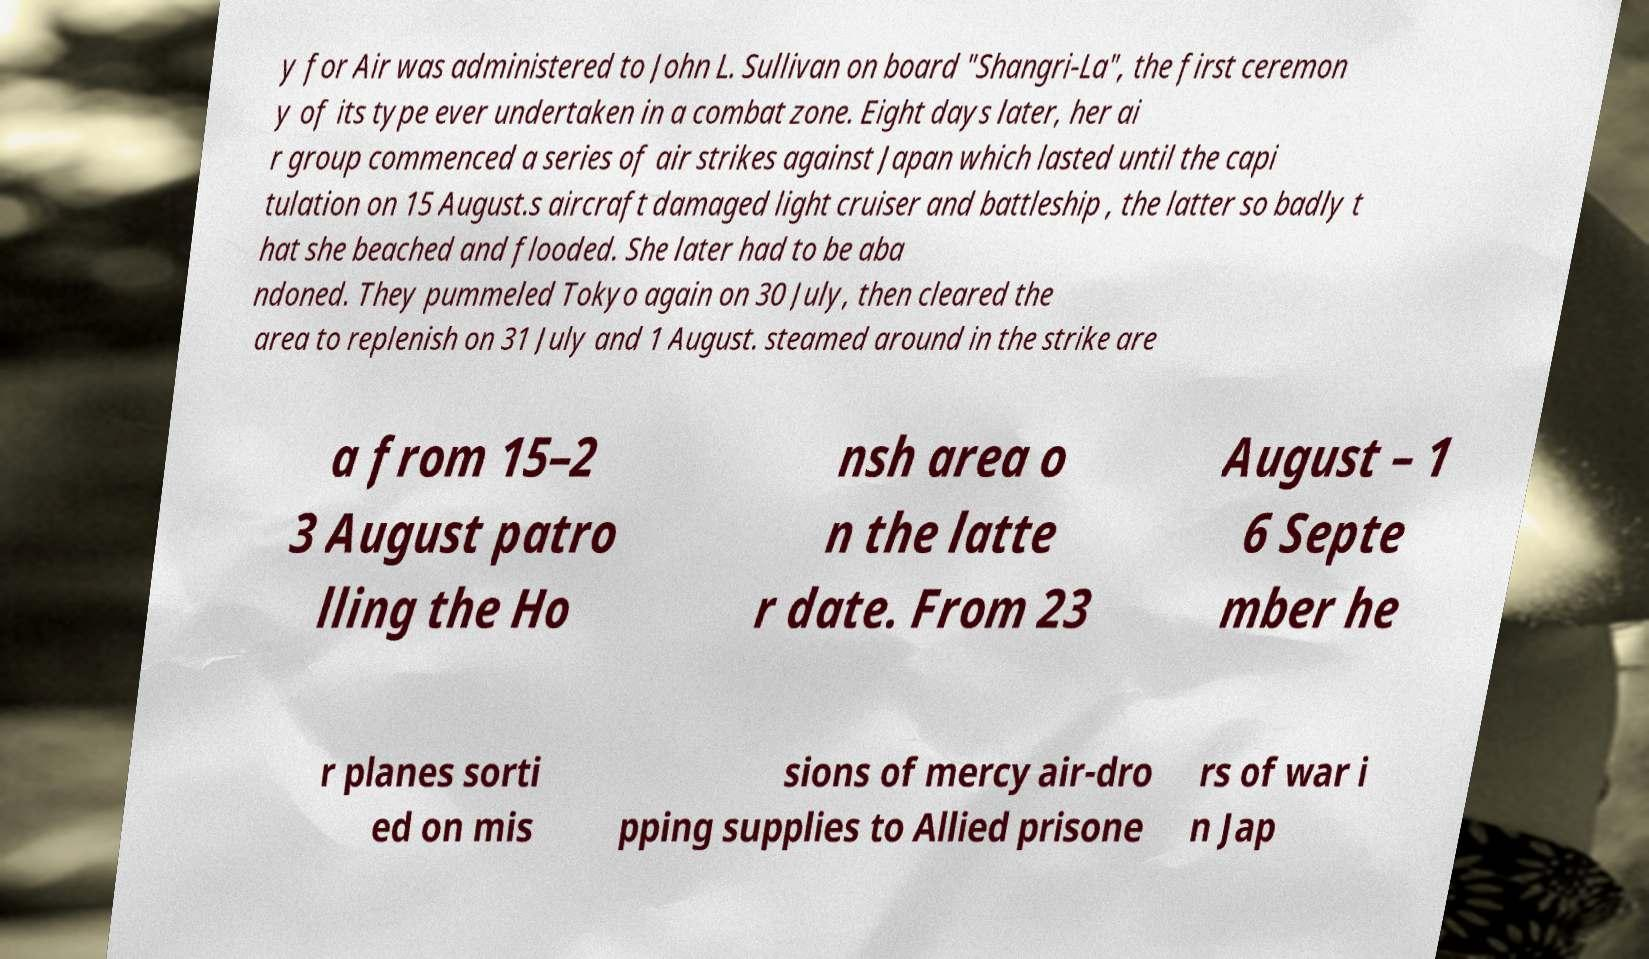Please read and relay the text visible in this image. What does it say? y for Air was administered to John L. Sullivan on board "Shangri-La", the first ceremon y of its type ever undertaken in a combat zone. Eight days later, her ai r group commenced a series of air strikes against Japan which lasted until the capi tulation on 15 August.s aircraft damaged light cruiser and battleship , the latter so badly t hat she beached and flooded. She later had to be aba ndoned. They pummeled Tokyo again on 30 July, then cleared the area to replenish on 31 July and 1 August. steamed around in the strike are a from 15–2 3 August patro lling the Ho nsh area o n the latte r date. From 23 August – 1 6 Septe mber he r planes sorti ed on mis sions of mercy air-dro pping supplies to Allied prisone rs of war i n Jap 